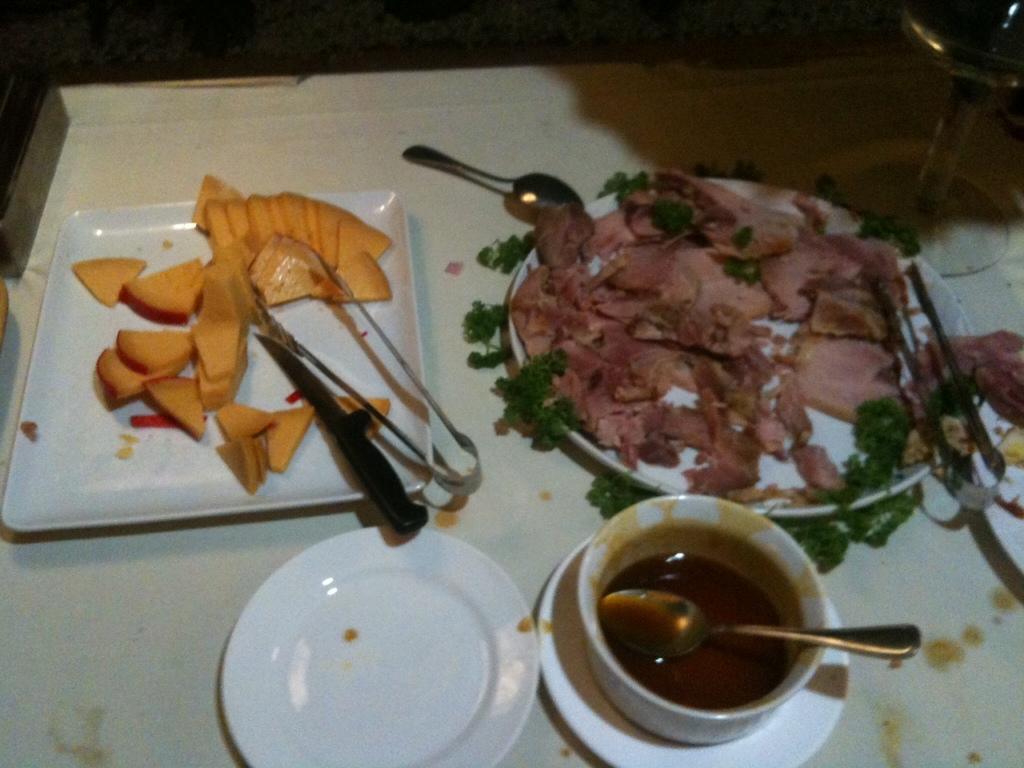What is present on the plates in the image? There is food on plates in the image. What can be used to eat the food on the plates? There are utensils in the image. What type of container is present for holding a beverage? There is a drink glass at the right side of the image. How many minutes does it take for the face on the plate to smile? There is no face present on the plate in the image, so it is not possible to determine how long it would take for it to smile. 